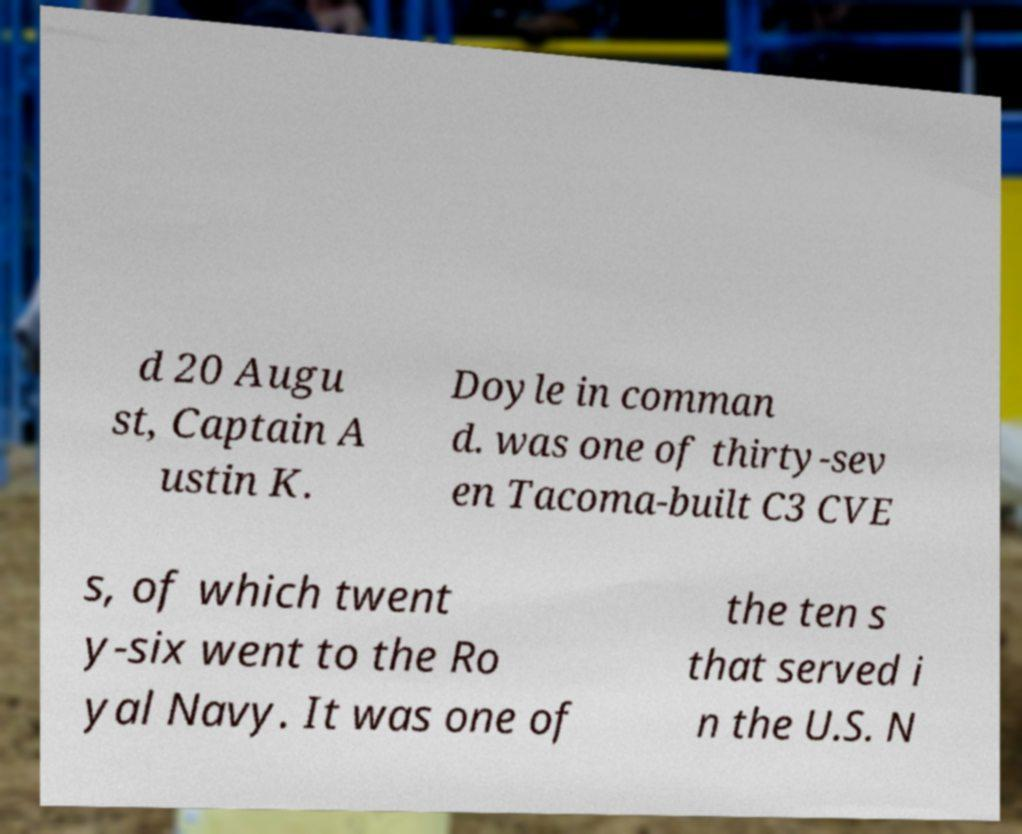Could you extract and type out the text from this image? d 20 Augu st, Captain A ustin K. Doyle in comman d. was one of thirty-sev en Tacoma-built C3 CVE s, of which twent y-six went to the Ro yal Navy. It was one of the ten s that served i n the U.S. N 